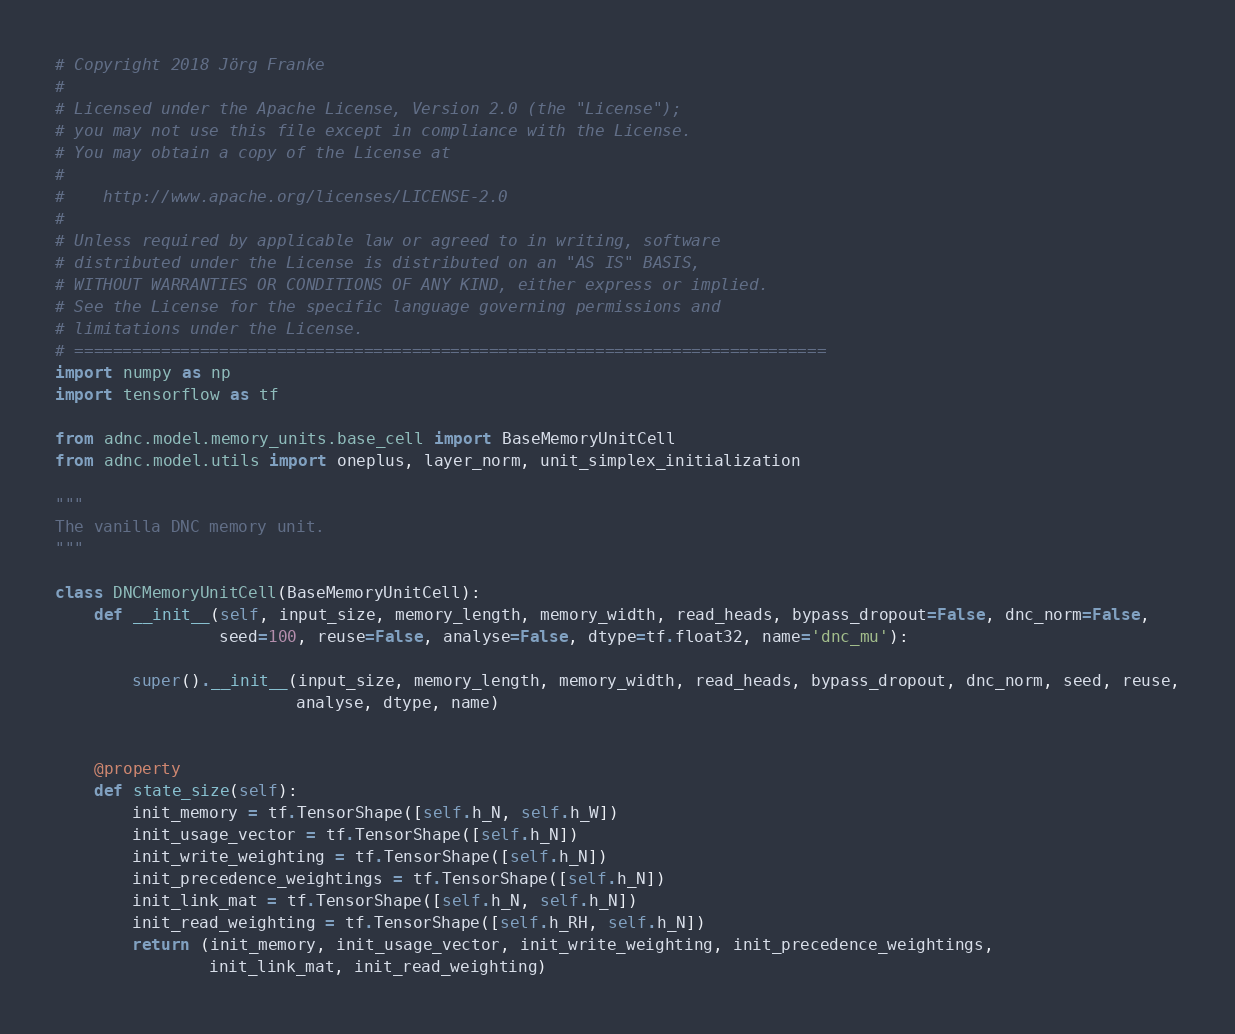Convert code to text. <code><loc_0><loc_0><loc_500><loc_500><_Python_># Copyright 2018 Jörg Franke
#
# Licensed under the Apache License, Version 2.0 (the "License");
# you may not use this file except in compliance with the License.
# You may obtain a copy of the License at
#
#    http://www.apache.org/licenses/LICENSE-2.0
#
# Unless required by applicable law or agreed to in writing, software
# distributed under the License is distributed on an "AS IS" BASIS,
# WITHOUT WARRANTIES OR CONDITIONS OF ANY KIND, either express or implied.
# See the License for the specific language governing permissions and
# limitations under the License.
# ==============================================================================
import numpy as np
import tensorflow as tf

from adnc.model.memory_units.base_cell import BaseMemoryUnitCell
from adnc.model.utils import oneplus, layer_norm, unit_simplex_initialization

"""
The vanilla DNC memory unit.
"""

class DNCMemoryUnitCell(BaseMemoryUnitCell):
    def __init__(self, input_size, memory_length, memory_width, read_heads, bypass_dropout=False, dnc_norm=False,
                 seed=100, reuse=False, analyse=False, dtype=tf.float32, name='dnc_mu'):

        super().__init__(input_size, memory_length, memory_width, read_heads, bypass_dropout, dnc_norm, seed, reuse,
                         analyse, dtype, name)


    @property
    def state_size(self):
        init_memory = tf.TensorShape([self.h_N, self.h_W])
        init_usage_vector = tf.TensorShape([self.h_N])
        init_write_weighting = tf.TensorShape([self.h_N])
        init_precedence_weightings = tf.TensorShape([self.h_N])
        init_link_mat = tf.TensorShape([self.h_N, self.h_N])
        init_read_weighting = tf.TensorShape([self.h_RH, self.h_N])
        return (init_memory, init_usage_vector, init_write_weighting, init_precedence_weightings,
                init_link_mat, init_read_weighting)
</code> 